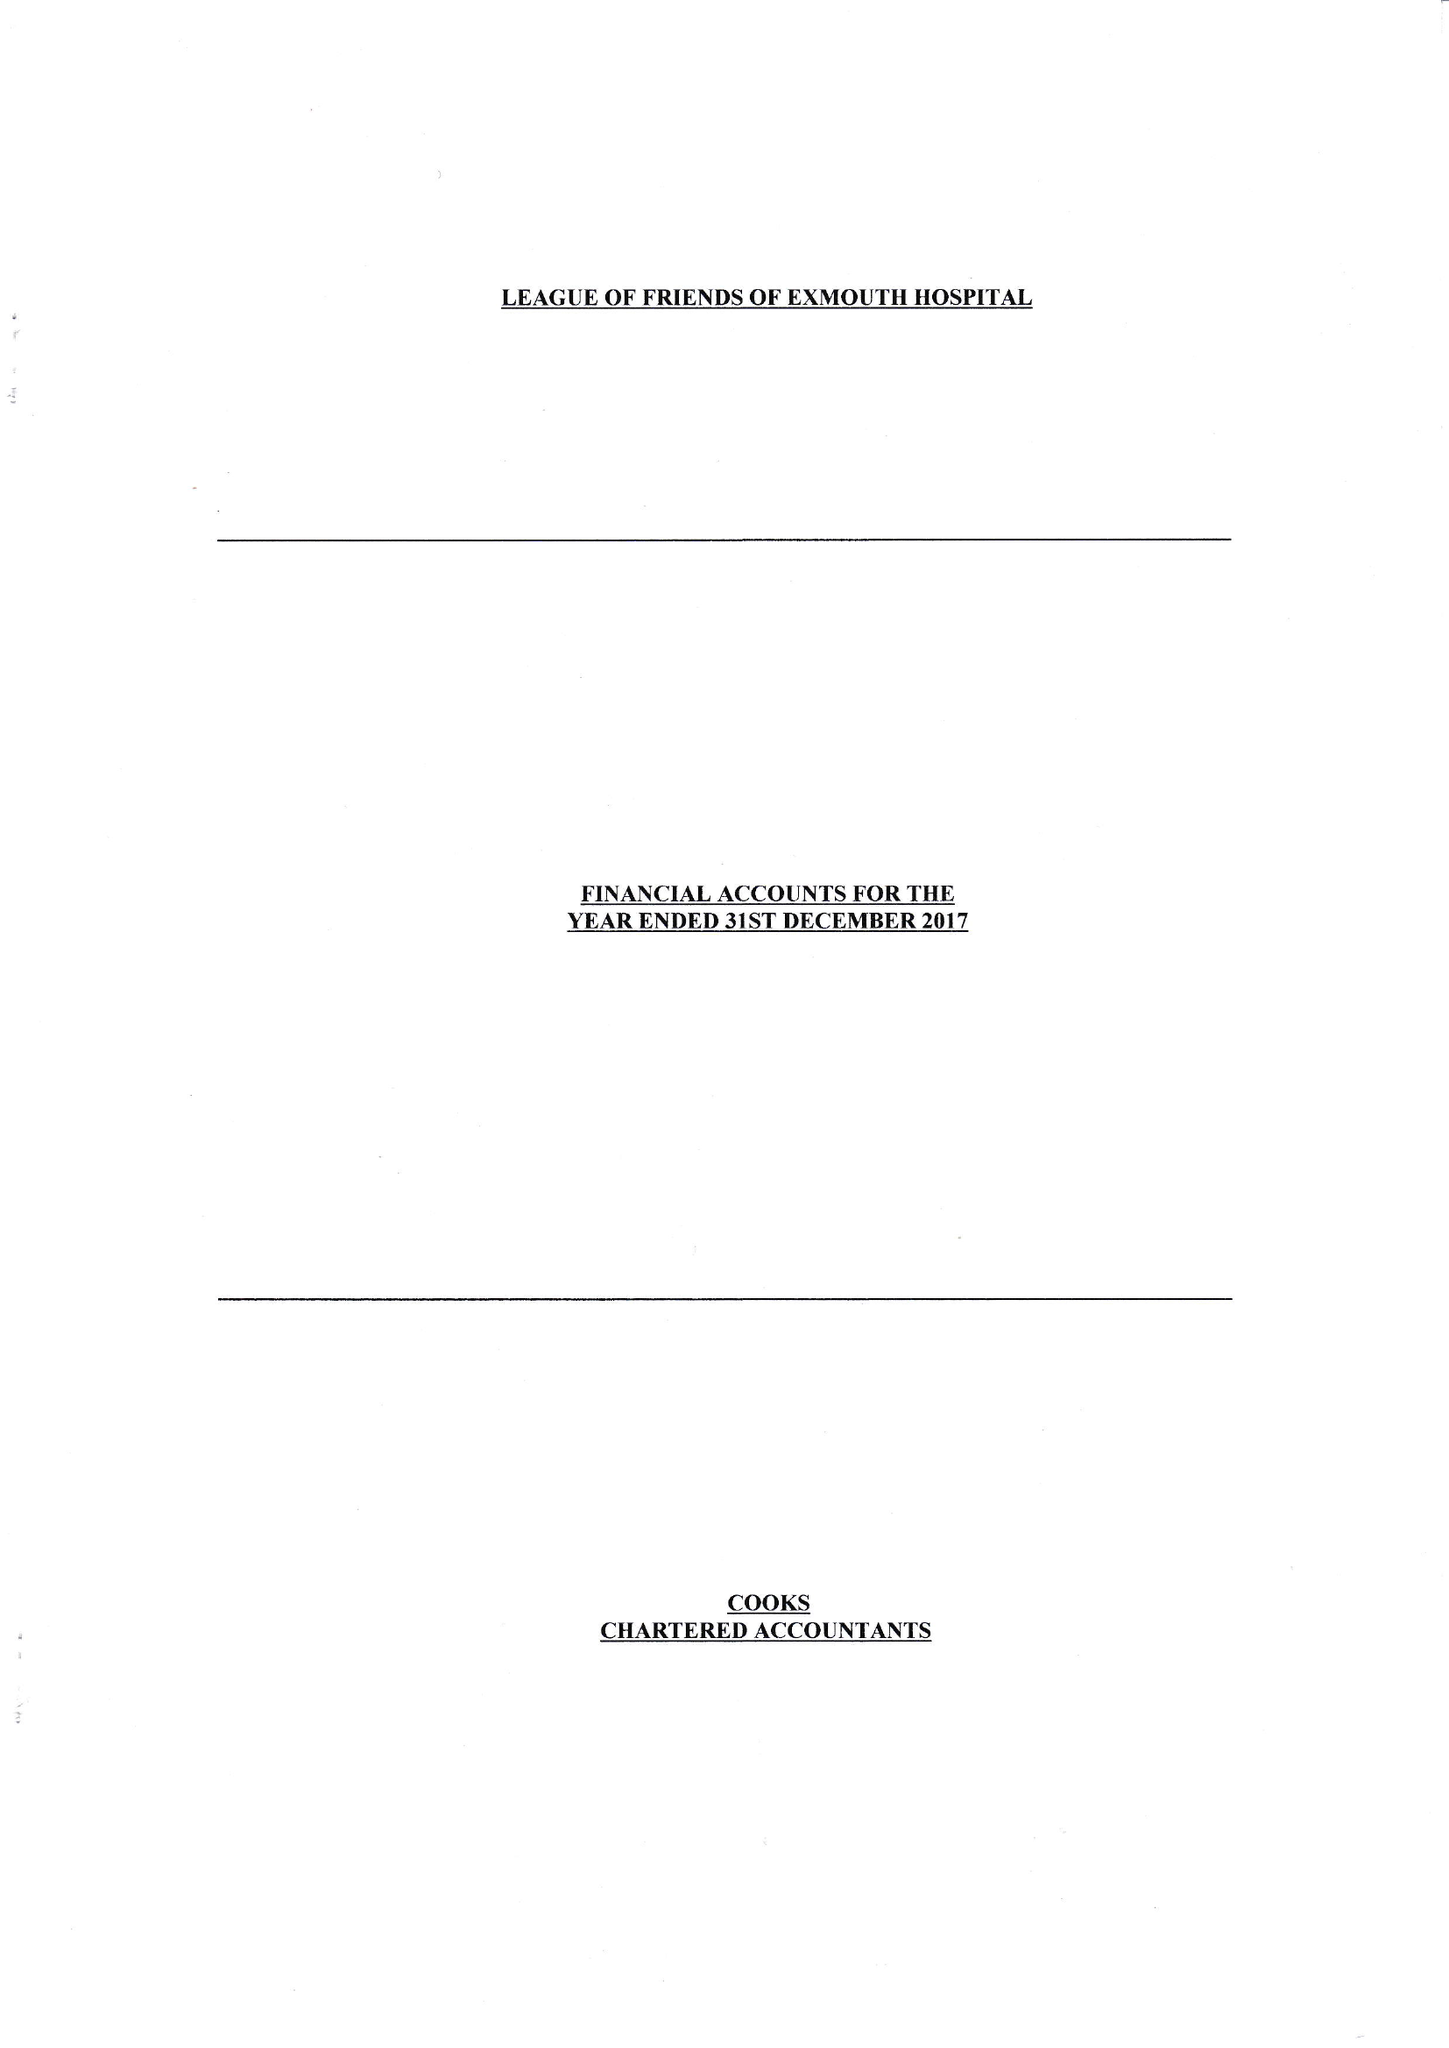What is the value for the address__street_line?
Answer the question using a single word or phrase. CLAREMONT GROVE 